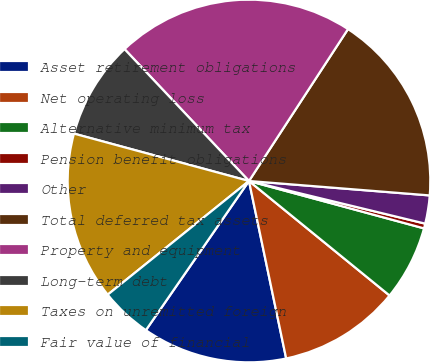Convert chart. <chart><loc_0><loc_0><loc_500><loc_500><pie_chart><fcel>Asset retirement obligations<fcel>Net operating loss<fcel>Alternative minimum tax<fcel>Pension benefit obligations<fcel>Other<fcel>Total deferred tax assets<fcel>Property and equipment<fcel>Long-term debt<fcel>Taxes on unremitted foreign<fcel>Fair value of financial<nl><fcel>12.91%<fcel>10.83%<fcel>6.67%<fcel>0.43%<fcel>2.51%<fcel>17.07%<fcel>21.23%<fcel>8.75%<fcel>14.99%<fcel>4.59%<nl></chart> 